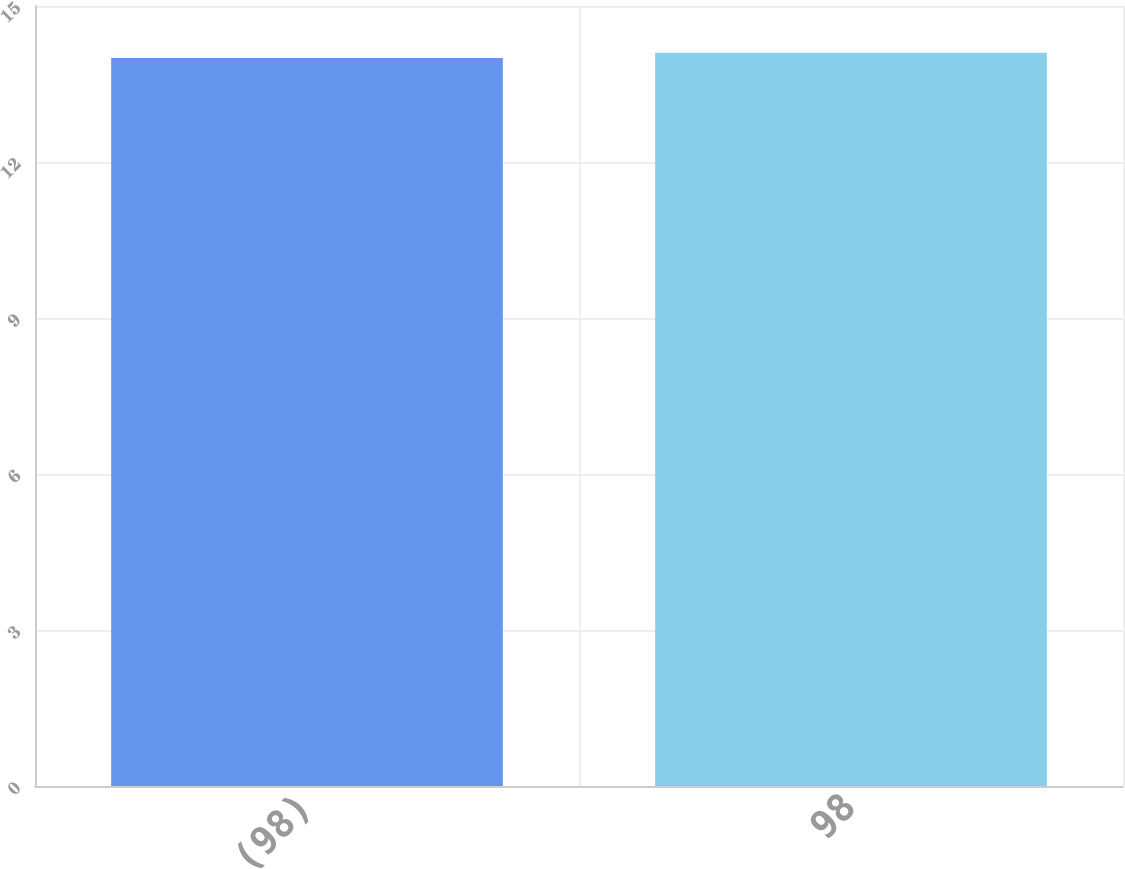Convert chart. <chart><loc_0><loc_0><loc_500><loc_500><bar_chart><fcel>(98)<fcel>98<nl><fcel>14<fcel>14.1<nl></chart> 